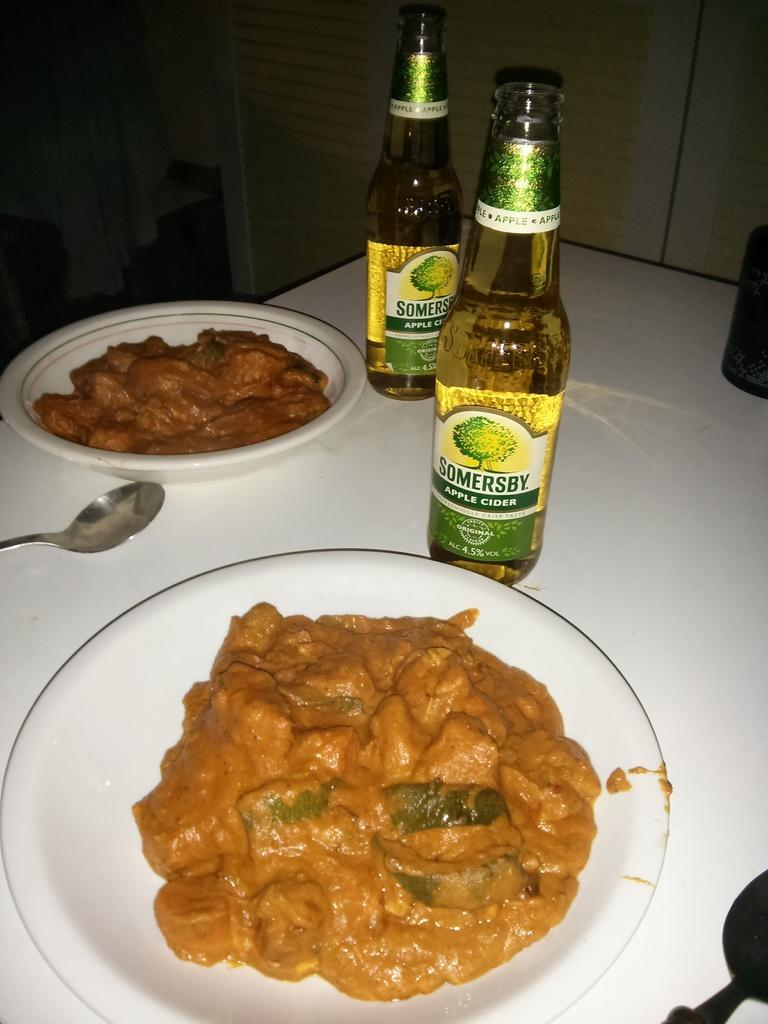<image>
Relay a brief, clear account of the picture shown. Two bottles of Somersby Apple cider are on a table with bowls of food. 